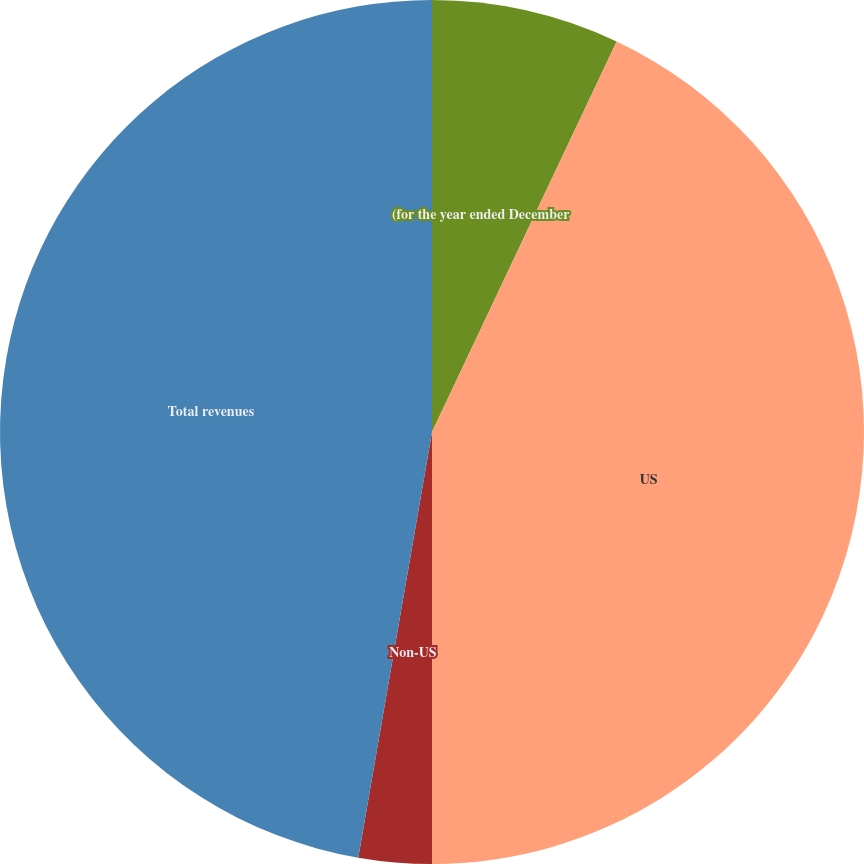Convert chart to OTSL. <chart><loc_0><loc_0><loc_500><loc_500><pie_chart><fcel>(for the year ended December<fcel>US<fcel>Non-US<fcel>Total revenues<nl><fcel>7.03%<fcel>42.97%<fcel>2.73%<fcel>47.27%<nl></chart> 